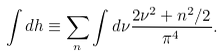Convert formula to latex. <formula><loc_0><loc_0><loc_500><loc_500>\int d h \equiv \sum _ { n } \int d \nu \frac { 2 \nu ^ { 2 } + n ^ { 2 } / 2 } { \pi ^ { 4 } } .</formula> 